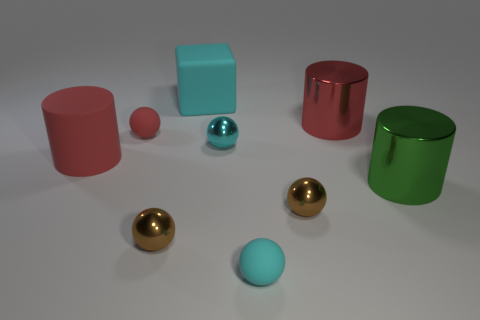Subtract 2 balls. How many balls are left? 3 Subtract all cyan matte spheres. How many spheres are left? 4 Subtract all red spheres. How many spheres are left? 4 Subtract all green spheres. Subtract all blue cubes. How many spheres are left? 5 Add 1 red matte things. How many objects exist? 10 Subtract all cylinders. How many objects are left? 6 Add 2 tiny red rubber objects. How many tiny red rubber objects are left? 3 Add 5 big yellow metal balls. How many big yellow metal balls exist? 5 Subtract 0 brown cylinders. How many objects are left? 9 Subtract all cyan metallic objects. Subtract all brown metallic spheres. How many objects are left? 6 